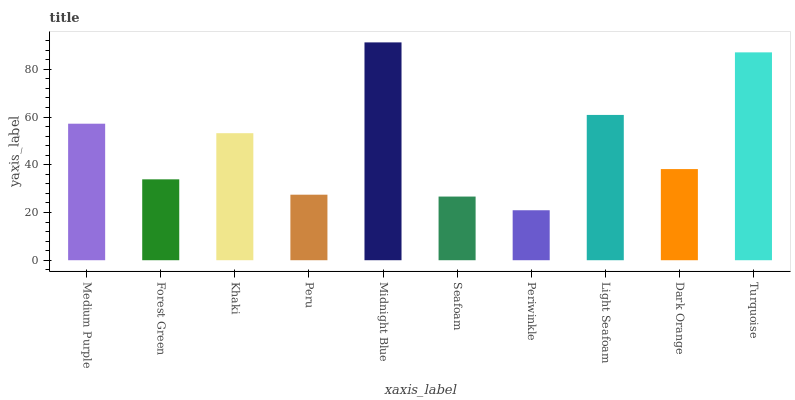Is Forest Green the minimum?
Answer yes or no. No. Is Forest Green the maximum?
Answer yes or no. No. Is Medium Purple greater than Forest Green?
Answer yes or no. Yes. Is Forest Green less than Medium Purple?
Answer yes or no. Yes. Is Forest Green greater than Medium Purple?
Answer yes or no. No. Is Medium Purple less than Forest Green?
Answer yes or no. No. Is Khaki the high median?
Answer yes or no. Yes. Is Dark Orange the low median?
Answer yes or no. Yes. Is Turquoise the high median?
Answer yes or no. No. Is Seafoam the low median?
Answer yes or no. No. 